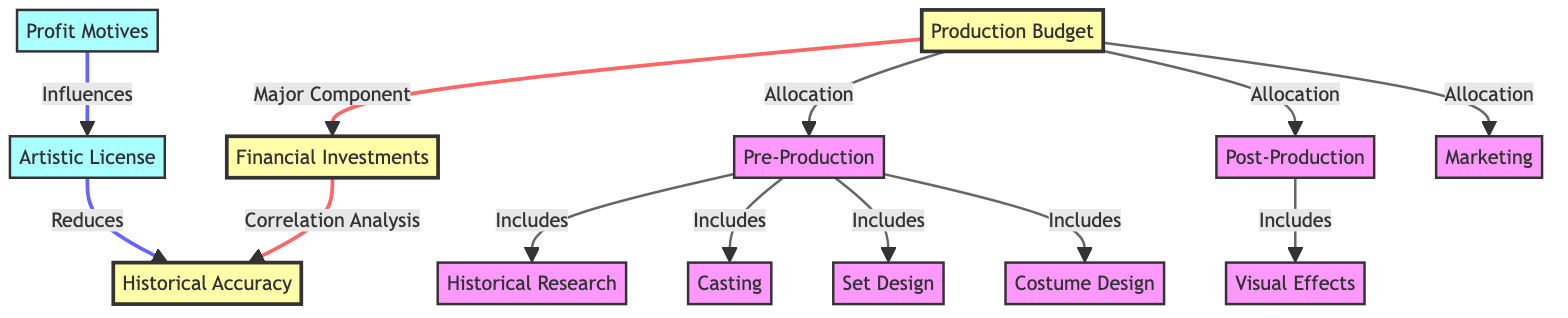What is the main component of financial investments? In the diagram, the arrow from 'Production Budget' to 'Financial Investments' indicates that the production budget is a major component contributing to financial investments.
Answer: Production Budget How many categories are included in pre-production? The diagram shows four categories, which are 'Research,' 'Casting,' 'Set Design,' and 'Costume Design,' connected to 'Pre-Production.' Therefore, the total number of categories included is four.
Answer: Four What influences artistic license according to the diagram? The influence arrow pointing from 'Profit Motives' to 'Artistic License' signifies that profit motives are the factors that influence artistic license in historical films.
Answer: Profit Motives How does artistic license affect historical accuracy? The diagram presents that 'Artistic License' has a 'Reduces' relationship with 'Historical Accuracy,' indicating that artistic license negatively impacts how accurate a film is historically.
Answer: Reduces Which element in post-production is included according to the diagram? The diagram indicates that 'Visual Effects' is included in the 'Post-Production' phase, as shown by the connection between the two nodes.
Answer: Visual Effects What happens to historical accuracy when profit motives are involved? According to the diagram, the line connecting 'Profit Motives' to 'Artistic License' suggests that if profit motives are strong, they can lead to an increase in artistic license, which in turn reduces historical accuracy.
Answer: Reduces What arrows point towards historical accuracy? The diagram shows one arrow pointing to 'Historical Accuracy' from 'Financial Investments,' indicating this relationship. Thus there is only one direct input leading to historical accuracy in the diagram.
Answer: One What category is a major component of the production budget? The diagram indicates that 'Production Budget' is the connection to multiple subcategories, including 'Pre-Production' and 'Post-Production,' meaning they are all key facets of the overall budget.
Answer: Pre-Production How many total nodes are there in this diagram? By counting all individual nodes shown in the diagram, including 'Financial Investments,' 'Historical Accuracy,' 'Production Budget,' and others, the total comes to fourteen distinct nodes.
Answer: Fourteen 